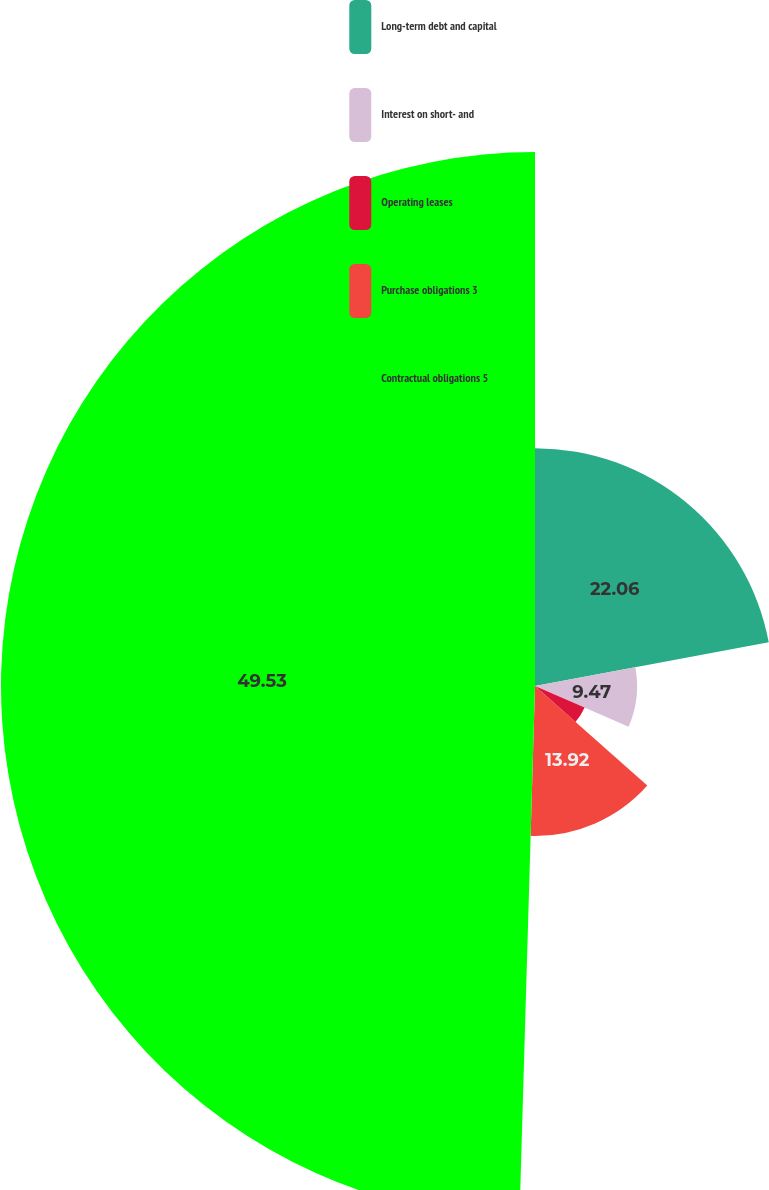<chart> <loc_0><loc_0><loc_500><loc_500><pie_chart><fcel>Long-term debt and capital<fcel>Interest on short- and<fcel>Operating leases<fcel>Purchase obligations 3<fcel>Contractual obligations 5<nl><fcel>22.06%<fcel>9.47%<fcel>5.02%<fcel>13.92%<fcel>49.54%<nl></chart> 